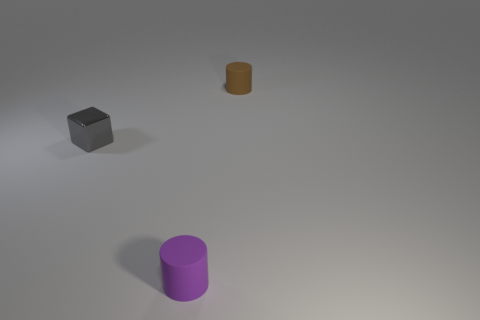What number of tiny things are both to the left of the tiny purple thing and on the right side of the tiny shiny thing?
Give a very brief answer. 0. There is a cube that is the same size as the purple rubber cylinder; what material is it?
Give a very brief answer. Metal. Do the matte cylinder that is behind the purple cylinder and the rubber object that is in front of the gray cube have the same size?
Offer a very short reply. Yes. Are there any metal things left of the tiny shiny cube?
Make the answer very short. No. The tiny object to the right of the tiny cylinder that is in front of the gray thing is what color?
Your answer should be very brief. Brown. Are there fewer cylinders than brown matte cylinders?
Provide a succinct answer. No. What number of gray objects are the same shape as the tiny purple object?
Provide a succinct answer. 0. The metallic thing that is the same size as the brown rubber cylinder is what color?
Make the answer very short. Gray. Are there an equal number of tiny matte objects that are on the left side of the tiny metal block and cylinders in front of the small brown matte cylinder?
Give a very brief answer. No. Is there a purple rubber cylinder of the same size as the gray cube?
Ensure brevity in your answer.  Yes. 